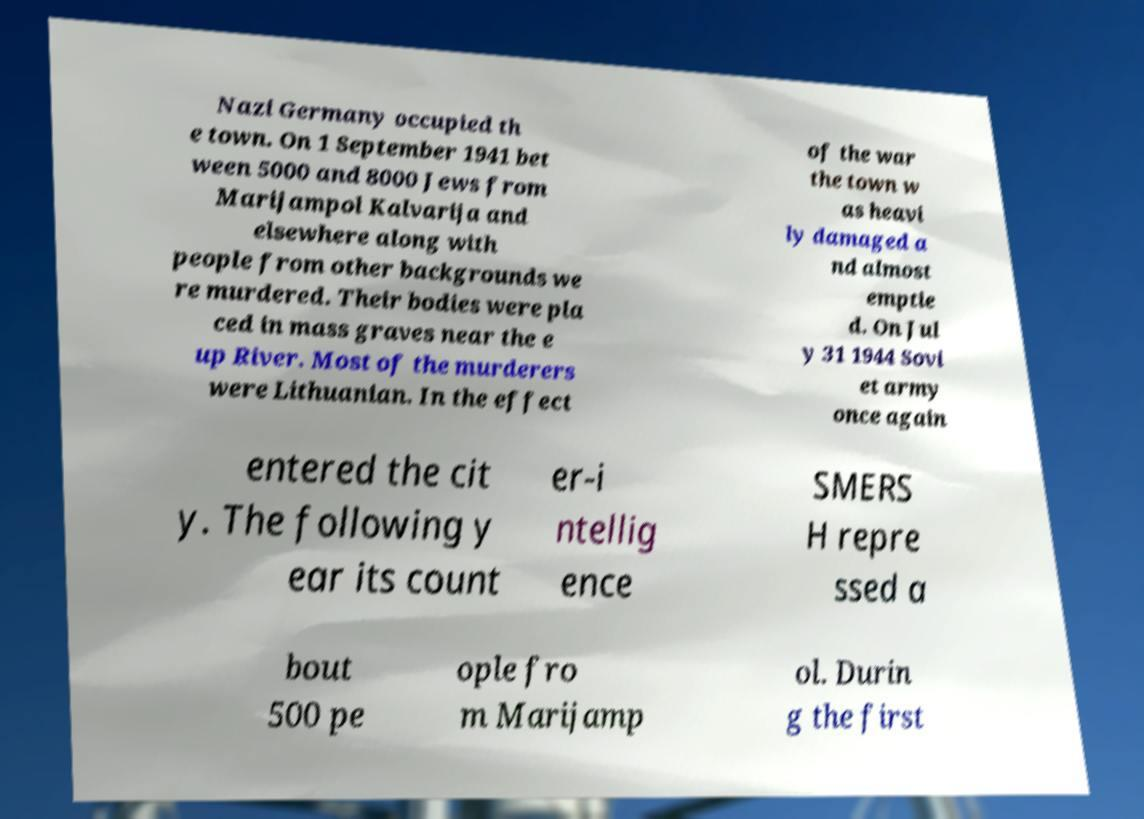Can you accurately transcribe the text from the provided image for me? Nazi Germany occupied th e town. On 1 September 1941 bet ween 5000 and 8000 Jews from Marijampol Kalvarija and elsewhere along with people from other backgrounds we re murdered. Their bodies were pla ced in mass graves near the e up River. Most of the murderers were Lithuanian. In the effect of the war the town w as heavi ly damaged a nd almost emptie d. On Jul y 31 1944 Sovi et army once again entered the cit y. The following y ear its count er-i ntellig ence SMERS H repre ssed a bout 500 pe ople fro m Marijamp ol. Durin g the first 